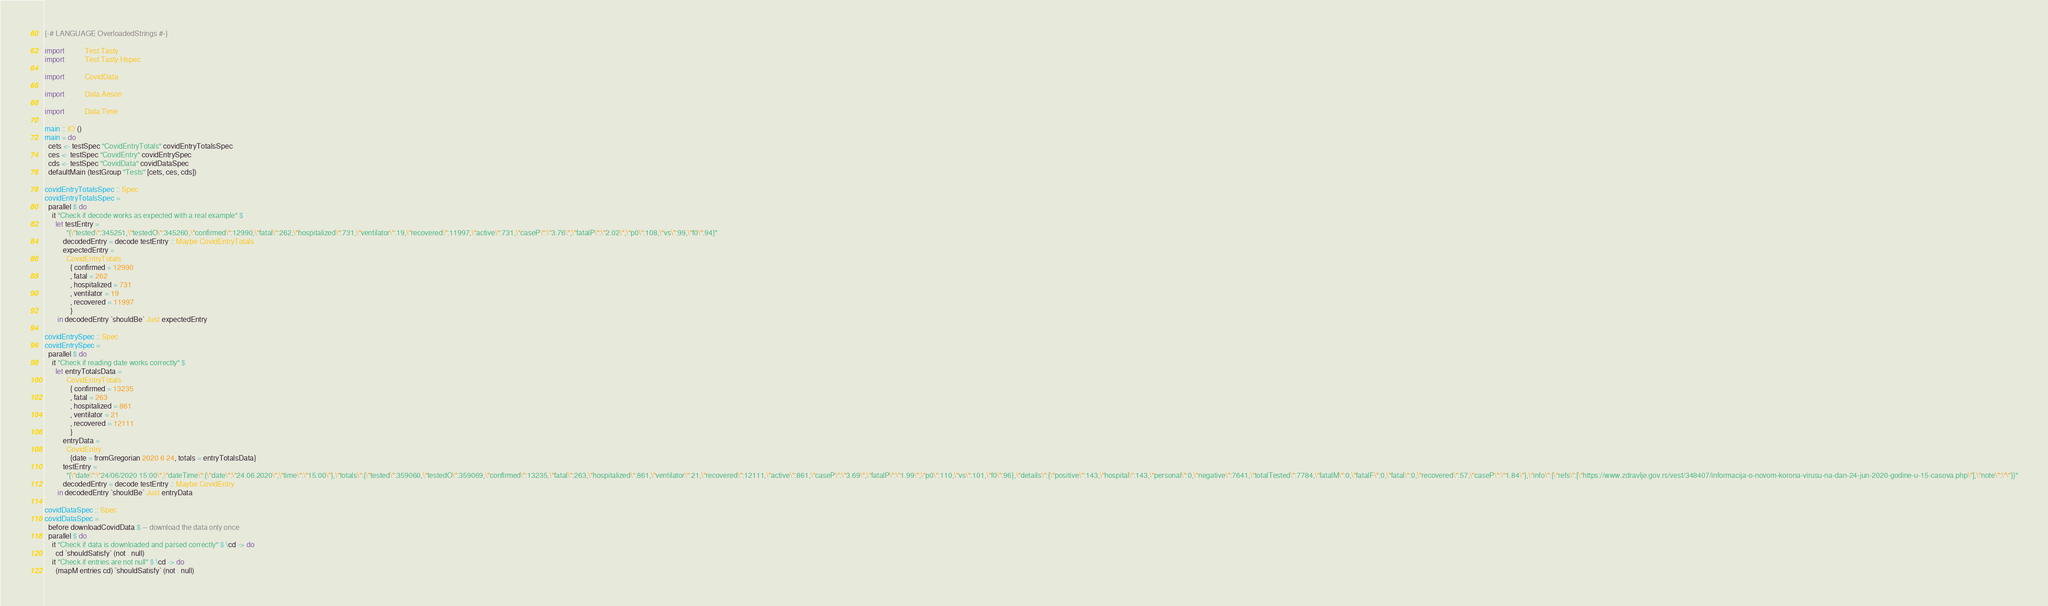<code> <loc_0><loc_0><loc_500><loc_500><_Haskell_>{-# LANGUAGE OverloadedStrings #-}

import           Test.Tasty
import           Test.Tasty.Hspec

import           CovidData

import           Data.Aeson

import           Data.Time

main :: IO ()
main = do
  cets <- testSpec "CovidEntryTotals" covidEntryTotalsSpec
  ces <- testSpec "CovidEntry" covidEntrySpec
  cds <- testSpec "CovidData" covidDataSpec
  defaultMain (testGroup "Tests" [cets, ces, cds])

covidEntryTotalsSpec :: Spec
covidEntryTotalsSpec =
  parallel $ do
    it "Check if decode works as expected with a real example" $
      let testEntry =
            "{\"tested\":345251,\"testedO\":345260,\"confirmed\":12990,\"fatal\":262,\"hospitalized\":731,\"ventilator\":19,\"recovered\":11997,\"active\":731,\"caseP\":\"3.76\",\"fatalP\":\"2.02\",\"p0\":108,\"vs\":99,\"f0\":94}"
          decodedEntry = decode testEntry :: Maybe CovidEntryTotals
          expectedEntry =
            CovidEntryTotals
              { confirmed = 12990
              , fatal = 262
              , hospitalized = 731
              , ventilator = 19
              , recovered = 11997
              }
       in decodedEntry `shouldBe` Just expectedEntry

covidEntrySpec :: Spec
covidEntrySpec =
  parallel $ do
    it "Check if reading date works correctly" $
      let entryTotalsData =
            CovidEntryTotals
              { confirmed = 13235
              , fatal = 263
              , hospitalized = 861
              , ventilator = 21
              , recovered = 12111
              }
          entryData =
            CovidEntry
              {date = fromGregorian 2020 6 24, totals = entryTotalsData}
          testEntry =
            "{\"date\":\"24/06/2020 15:00\",\"dateTime\":{\"date\":\"24.06.2020\",\"time\":\"15:00\"},\"totals\":{\"tested\":359060,\"testedO\":359069,\"confirmed\":13235,\"fatal\":263,\"hospitalized\":861,\"ventilator\":21,\"recovered\":12111,\"active\":861,\"caseP\":\"3.69\",\"fatalP\":\"1.99\",\"p0\":110,\"vs\":101,\"f0\":96},\"details\":{\"positive\":143,\"hospital\":143,\"personal\":0,\"negative\":7641,\"totalTested\":7784,\"fatalM\":0,\"fatalF\":0,\"fatal\":0,\"recovered\":57,\"caseP\":\"1.84\"},\"info\":{\"refs\":[\"https://www.zdravlje.gov.rs/vest/348407/informacija-o-novom-korona-virusu-na-dan-24-jun-2020-godine-u-15-casova.php\"],\"note\":\"\"}}"
          decodedEntry = decode testEntry :: Maybe CovidEntry
       in decodedEntry `shouldBe` Just entryData

covidDataSpec :: Spec
covidDataSpec =
  before downloadCovidData $ -- download the data only once
  parallel $ do
    it "Check if data is downloaded and parsed correctly" $ \cd -> do
      cd `shouldSatisfy` (not . null)
    it "Check if entries are not null" $ \cd -> do
      (mapM entries cd) `shouldSatisfy` (not . null)
</code> 